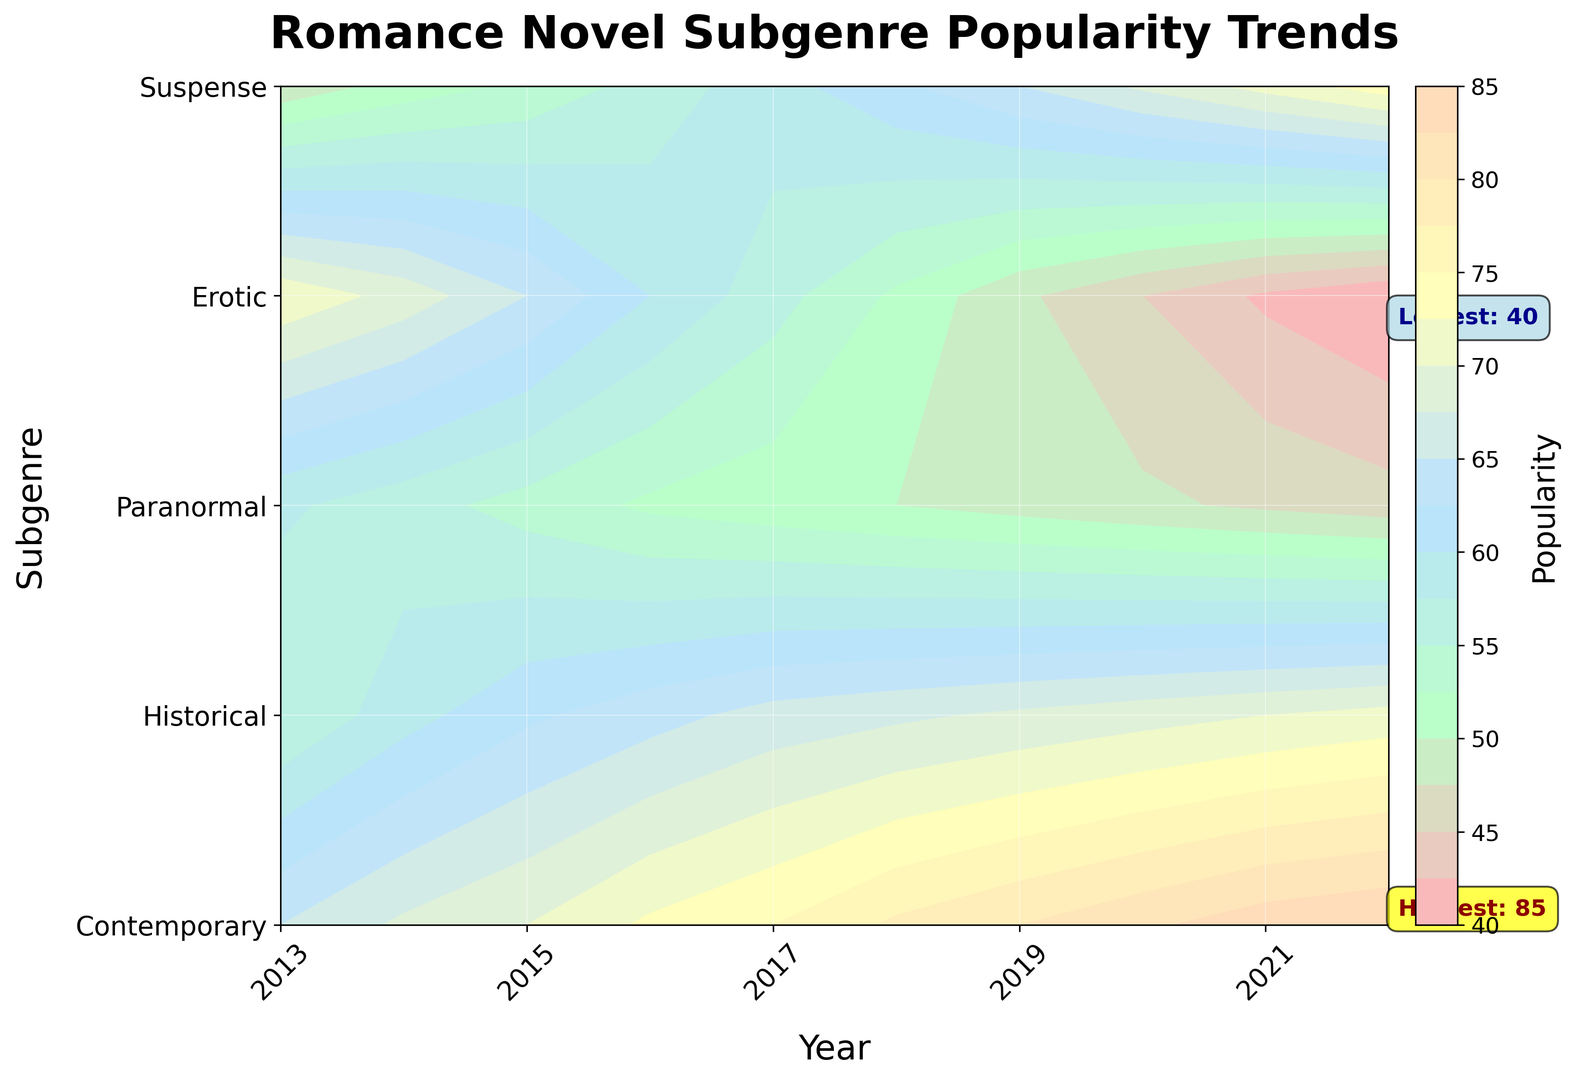What subgenre was the most popular in the year 2013? Look at the contour plot for the year 2013, find the subgenre with the highest numerical value.
Answer: Paranormal Which subgenre's popularity increased the most from 2013 to 2022? Track each subgenre's popularity from 2013 to 2022 and identify which has the largest positive difference. Calculate the increase for each subgenre and compare them.
Answer: Suspense What years did the Contemporary subgenre see significant rises in popularity? Examine the contour plot and locate periods where the color gradient for the Contemporary subgenre steeply changes to a lighter color, indicating a rise in popularity.
Answer: 2016 to 2017, 2018 to 2019 Comparing Historical and Erotic subgenres, which saw the biggest decline in popularity over the decade? Compare the popularity values of both subgenres in 2013 and 2022, and identify the one with the largest negative difference.
Answer: Historical What is the average popularity of the Paranormal subgenre over the decade? Sum the yearly popularity values of Paranormal from 2013 to 2022 and divide by 10.
Answer: 53.9 Which subgenre had the highest popularity, and in what year did this occur? Look for the annotation indicating the highest popularity value in the contour plot and identify the subgenre and year.
Answer: Contemporary, 2022 What is the trend in popularity for the Historical subgenre over the years? Follow the color progression for the Historical subgenre in the contour plot to understand whether it’s rising, falling, or stable over time.
Answer: Falling In which year did the Suspense subgenre's popularity surpass 60 for the first time? Track the Suspense subgenre across the years and identify the first instance where its value exceeds 60.
Answer: 2018 How does the popularity of the median subgenre in 2015 compare to that in 2022? Identify the middle value of popularity values for 2015 and 2022, and compare them.
Answer: Less in 2015 Which two subgenres were closest in popularity in the year 2020? Find the difference between the popularity values of all subgenres in 2020, and determine which two have the smallest difference.
Answer: Erotic and Suspense 